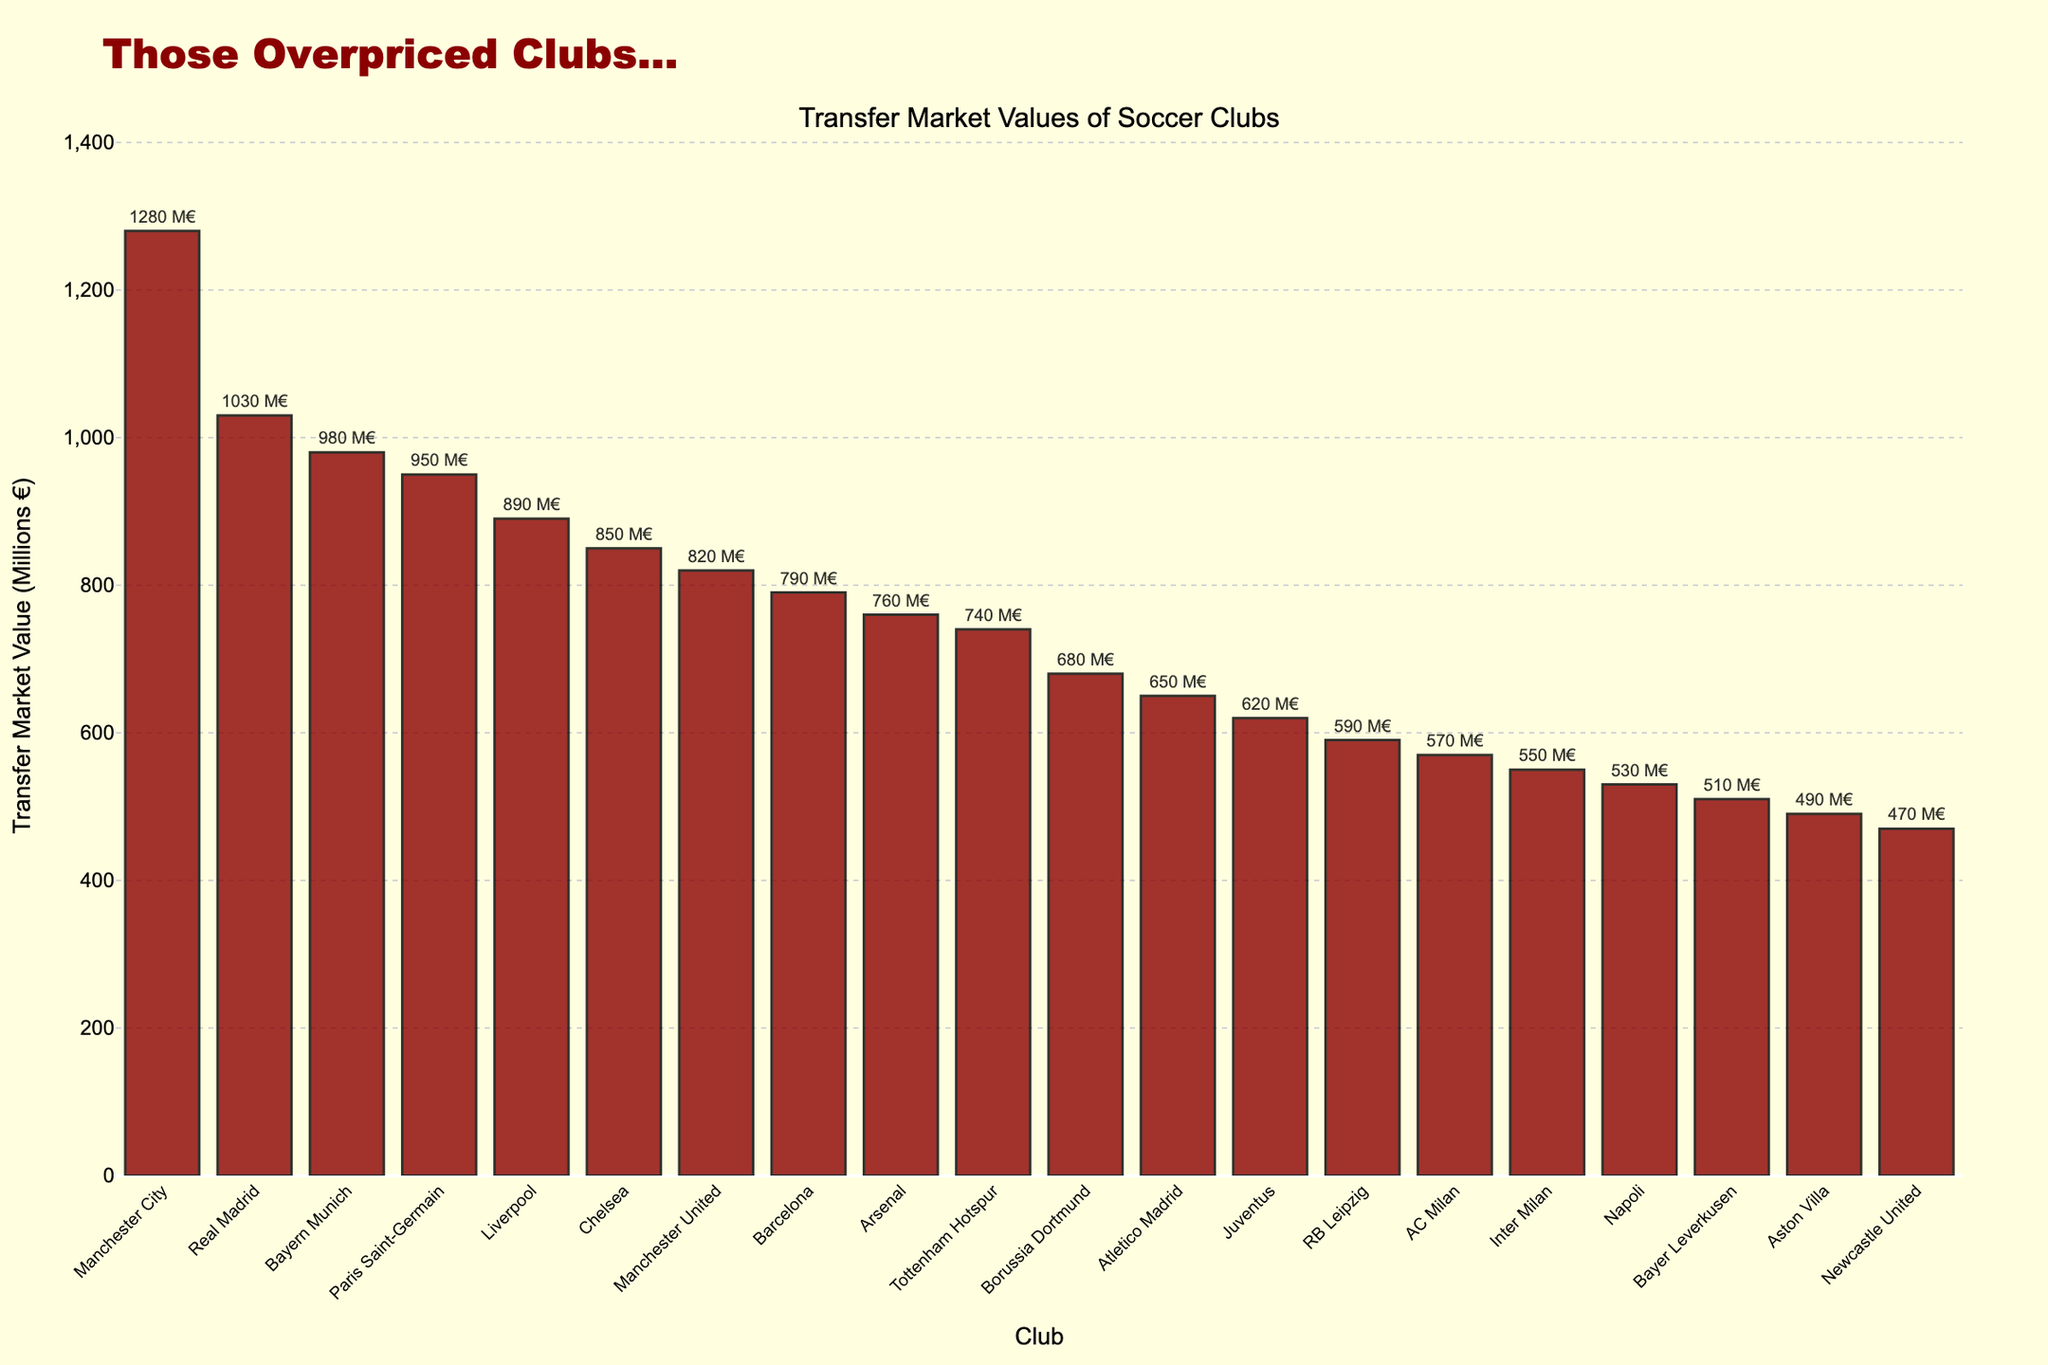What's the transfer market value of Chelsea? The bar representing Chelsea shows a value of 850 million euros, as indicated by the numerical label above the bar.
Answer: 850 million euros Which club has a higher transfer market value, Bayern Munich or Liverpool? The bar for Bayern Munich is taller and has a higher numerical value (980 million euros) compared to Liverpool (890 million euros).
Answer: Bayern Munich What's the total transfer market value of the top three clubs? The top three clubs are Manchester City, Real Madrid, and Bayern Munich with values of 1280, 1030, and 980 million euros respectively. Summing these values: 1280 + 1030 + 980 = 3290 million euros.
Answer: 3290 million euros How many clubs have a transfer market value greater than 1000 million euros? The only clubs with values greater than 1000 million euros are Manchester City (1280) and Real Madrid (1030). Therefore, there are 2 clubs.
Answer: 2 What's the difference in transfer market value between Arsenal and Tottenham Hotspur? Arsenal's transfer market value is 760 million euros, and Tottenham Hotspur's is 740 million euros. The difference is 760 - 740 = 20 million euros.
Answer: 20 million euros Is Patrick's team in the top 5 clubs by transfer market value? The top 5 clubs are Manchester City, Real Madrid, Bayern Munich, Paris Saint-Germain, and Liverpool. Patrick's team is not listed among the competitors, so it's clear his team is not in the top 5.
Answer: No Which club has the closest transfer market value to Borussia Dortmund? Borussia Dortmund has a value of 680 million euros. The closest value is Atletico Madrid with a value of 650 million euros. The difference is 680 - 650 = 30 million euros.
Answer: Atletico Madrid What's the average transfer market value of the clubs listed? Summing the market values: 1280 + 1030 + 980 + 950 + 890 + 850 + 820 + 790 + 760 + 740 + 680 + 650 + 620 + 590 + 570 + 550 + 530 + 510 + 490 + 470 = 16030 million euros. There are 20 clubs, so the average is 16030 / 20 = 801.5 million euros.
Answer: 801.5 million euros Which clubs have a transfer market value less than 600 million euros? The clubs with values below 600 million euros are RB Leipzig (590), AC Milan (570), Inter Milan (550), Napoli (530), Bayer Leverkusen (510), Aston Villa (490), and Newcastle United (470).
Answer: RB Leipzig, AC Milan, Inter Milan, Napoli, Bayer Leverkusen, Aston Villa, Newcastle United What is the combined transfer market value of the Italian clubs listed? The Italian clubs listed are Juventus (620), AC Milan (570), Inter Milan (550), and Napoli (530). Their combined value is 620 + 570 + 550 + 530 = 2270 million euros.
Answer: 2270 million euros 